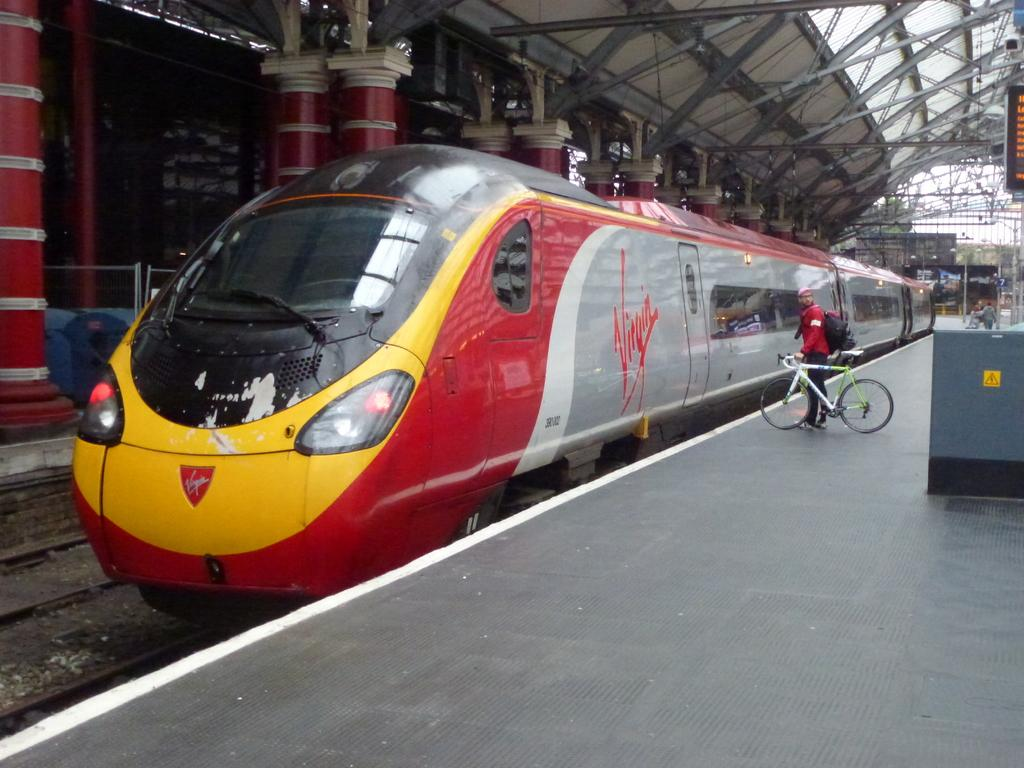<image>
Give a short and clear explanation of the subsequent image. A red and grey train with Virgin on the side stops at the station to let a person on 